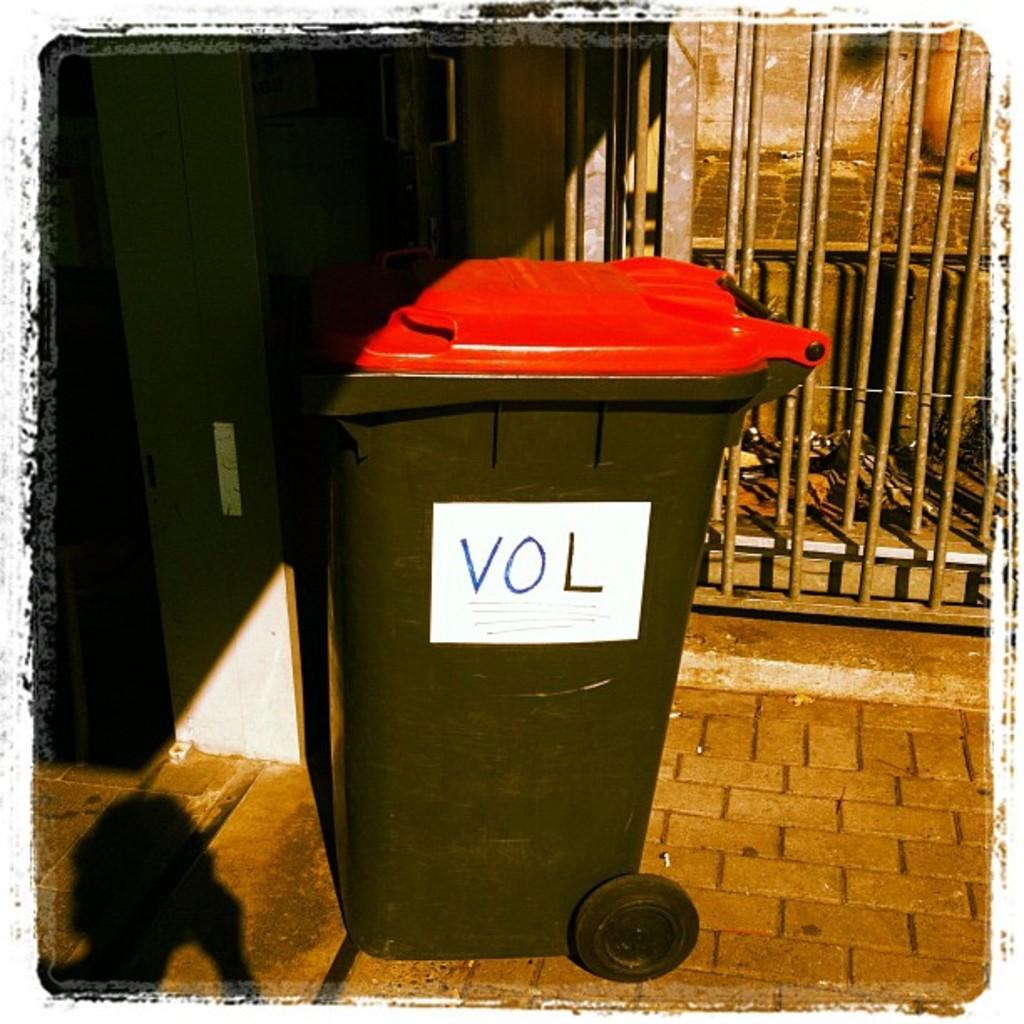Provide a one-sentence caption for the provided image. a red and black trash can with the letters vol on it. 